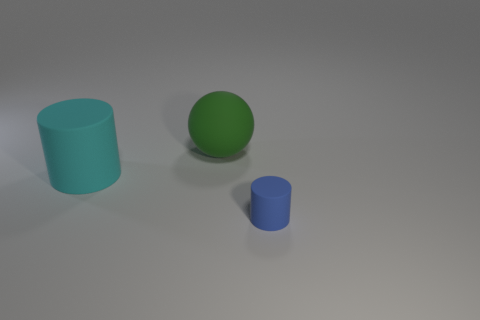Add 3 big objects. How many objects exist? 6 Subtract all balls. How many objects are left? 2 Subtract all brown spheres. Subtract all cylinders. How many objects are left? 1 Add 3 small rubber cylinders. How many small rubber cylinders are left? 4 Add 1 spheres. How many spheres exist? 2 Subtract 0 yellow spheres. How many objects are left? 3 